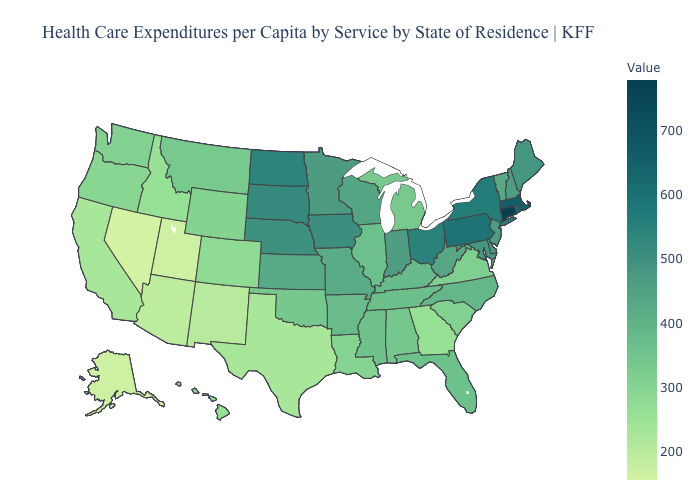Among the states that border Wyoming , which have the highest value?
Concise answer only. South Dakota. Does Pennsylvania have a higher value than Massachusetts?
Quick response, please. No. Among the states that border Ohio , does Pennsylvania have the lowest value?
Answer briefly. No. Does Connecticut have the highest value in the USA?
Keep it brief. Yes. 